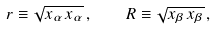Convert formula to latex. <formula><loc_0><loc_0><loc_500><loc_500>r \equiv \sqrt { x _ { \alpha } \, x _ { \alpha } } \, , \quad R \equiv \sqrt { x _ { \beta } \, x _ { \beta } } \, ,</formula> 